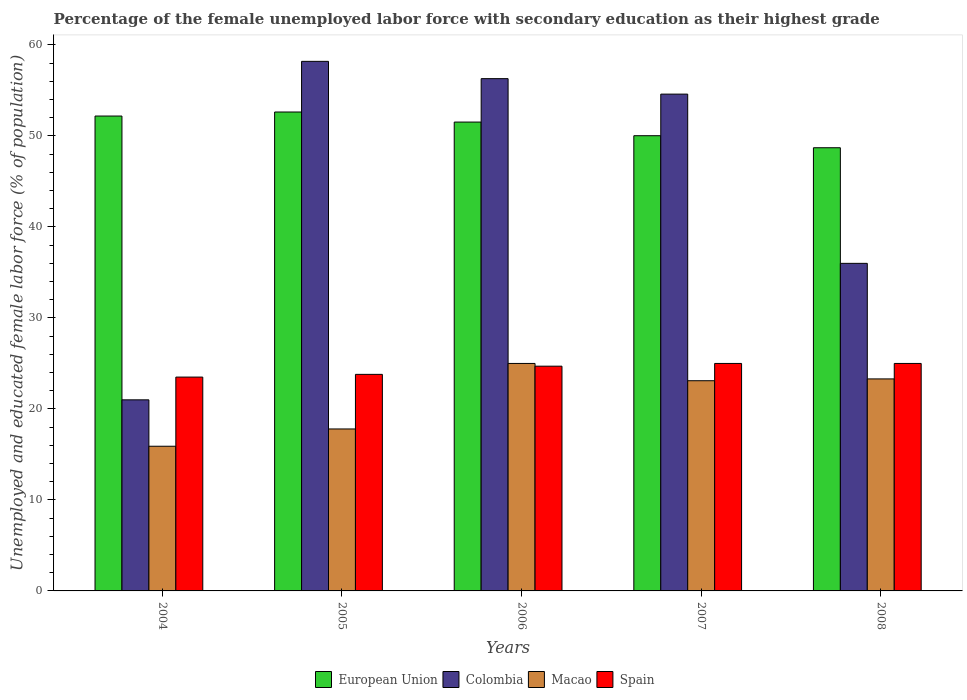Are the number of bars per tick equal to the number of legend labels?
Your answer should be compact. Yes. What is the label of the 1st group of bars from the left?
Your answer should be compact. 2004. What is the percentage of the unemployed female labor force with secondary education in Spain in 2007?
Offer a very short reply. 25. Across all years, what is the maximum percentage of the unemployed female labor force with secondary education in Macao?
Provide a succinct answer. 25. Across all years, what is the minimum percentage of the unemployed female labor force with secondary education in Macao?
Offer a terse response. 15.9. What is the total percentage of the unemployed female labor force with secondary education in European Union in the graph?
Your answer should be very brief. 255.08. What is the difference between the percentage of the unemployed female labor force with secondary education in Spain in 2005 and that in 2007?
Your response must be concise. -1.2. What is the difference between the percentage of the unemployed female labor force with secondary education in Spain in 2005 and the percentage of the unemployed female labor force with secondary education in Macao in 2004?
Your answer should be compact. 7.9. What is the average percentage of the unemployed female labor force with secondary education in Spain per year?
Offer a terse response. 24.4. In the year 2007, what is the difference between the percentage of the unemployed female labor force with secondary education in Spain and percentage of the unemployed female labor force with secondary education in Colombia?
Offer a very short reply. -29.6. In how many years, is the percentage of the unemployed female labor force with secondary education in European Union greater than 44 %?
Your response must be concise. 5. What is the ratio of the percentage of the unemployed female labor force with secondary education in Colombia in 2004 to that in 2005?
Make the answer very short. 0.36. Is the percentage of the unemployed female labor force with secondary education in Colombia in 2006 less than that in 2008?
Your response must be concise. No. Is the difference between the percentage of the unemployed female labor force with secondary education in Spain in 2006 and 2008 greater than the difference between the percentage of the unemployed female labor force with secondary education in Colombia in 2006 and 2008?
Give a very brief answer. No. What is the difference between the highest and the second highest percentage of the unemployed female labor force with secondary education in Spain?
Give a very brief answer. 0. What is the difference between the highest and the lowest percentage of the unemployed female labor force with secondary education in Macao?
Your answer should be compact. 9.1. In how many years, is the percentage of the unemployed female labor force with secondary education in Spain greater than the average percentage of the unemployed female labor force with secondary education in Spain taken over all years?
Offer a very short reply. 3. What does the 1st bar from the left in 2006 represents?
Your answer should be compact. European Union. What does the 1st bar from the right in 2006 represents?
Provide a succinct answer. Spain. How many bars are there?
Offer a terse response. 20. How many years are there in the graph?
Offer a terse response. 5. What is the difference between two consecutive major ticks on the Y-axis?
Offer a very short reply. 10. Does the graph contain grids?
Keep it short and to the point. No. What is the title of the graph?
Offer a very short reply. Percentage of the female unemployed labor force with secondary education as their highest grade. Does "United Kingdom" appear as one of the legend labels in the graph?
Offer a terse response. No. What is the label or title of the X-axis?
Your response must be concise. Years. What is the label or title of the Y-axis?
Give a very brief answer. Unemployed and educated female labor force (% of population). What is the Unemployed and educated female labor force (% of population) in European Union in 2004?
Keep it short and to the point. 52.19. What is the Unemployed and educated female labor force (% of population) of Macao in 2004?
Ensure brevity in your answer.  15.9. What is the Unemployed and educated female labor force (% of population) in Spain in 2004?
Ensure brevity in your answer.  23.5. What is the Unemployed and educated female labor force (% of population) in European Union in 2005?
Ensure brevity in your answer.  52.63. What is the Unemployed and educated female labor force (% of population) of Colombia in 2005?
Keep it short and to the point. 58.2. What is the Unemployed and educated female labor force (% of population) in Macao in 2005?
Your response must be concise. 17.8. What is the Unemployed and educated female labor force (% of population) in Spain in 2005?
Provide a succinct answer. 23.8. What is the Unemployed and educated female labor force (% of population) of European Union in 2006?
Provide a short and direct response. 51.53. What is the Unemployed and educated female labor force (% of population) in Colombia in 2006?
Provide a succinct answer. 56.3. What is the Unemployed and educated female labor force (% of population) of Macao in 2006?
Provide a succinct answer. 25. What is the Unemployed and educated female labor force (% of population) of Spain in 2006?
Your answer should be compact. 24.7. What is the Unemployed and educated female labor force (% of population) of European Union in 2007?
Your answer should be compact. 50.03. What is the Unemployed and educated female labor force (% of population) of Colombia in 2007?
Make the answer very short. 54.6. What is the Unemployed and educated female labor force (% of population) in Macao in 2007?
Provide a succinct answer. 23.1. What is the Unemployed and educated female labor force (% of population) in European Union in 2008?
Your answer should be compact. 48.71. What is the Unemployed and educated female labor force (% of population) in Macao in 2008?
Your response must be concise. 23.3. What is the Unemployed and educated female labor force (% of population) in Spain in 2008?
Give a very brief answer. 25. Across all years, what is the maximum Unemployed and educated female labor force (% of population) of European Union?
Give a very brief answer. 52.63. Across all years, what is the maximum Unemployed and educated female labor force (% of population) of Colombia?
Offer a terse response. 58.2. Across all years, what is the maximum Unemployed and educated female labor force (% of population) in Spain?
Your response must be concise. 25. Across all years, what is the minimum Unemployed and educated female labor force (% of population) of European Union?
Give a very brief answer. 48.71. Across all years, what is the minimum Unemployed and educated female labor force (% of population) of Colombia?
Give a very brief answer. 21. Across all years, what is the minimum Unemployed and educated female labor force (% of population) of Macao?
Your answer should be very brief. 15.9. What is the total Unemployed and educated female labor force (% of population) of European Union in the graph?
Offer a terse response. 255.08. What is the total Unemployed and educated female labor force (% of population) of Colombia in the graph?
Provide a short and direct response. 226.1. What is the total Unemployed and educated female labor force (% of population) in Macao in the graph?
Your answer should be compact. 105.1. What is the total Unemployed and educated female labor force (% of population) in Spain in the graph?
Your answer should be very brief. 122. What is the difference between the Unemployed and educated female labor force (% of population) of European Union in 2004 and that in 2005?
Ensure brevity in your answer.  -0.44. What is the difference between the Unemployed and educated female labor force (% of population) of Colombia in 2004 and that in 2005?
Provide a short and direct response. -37.2. What is the difference between the Unemployed and educated female labor force (% of population) in European Union in 2004 and that in 2006?
Offer a very short reply. 0.66. What is the difference between the Unemployed and educated female labor force (% of population) in Colombia in 2004 and that in 2006?
Provide a short and direct response. -35.3. What is the difference between the Unemployed and educated female labor force (% of population) in Spain in 2004 and that in 2006?
Ensure brevity in your answer.  -1.2. What is the difference between the Unemployed and educated female labor force (% of population) of European Union in 2004 and that in 2007?
Make the answer very short. 2.16. What is the difference between the Unemployed and educated female labor force (% of population) in Colombia in 2004 and that in 2007?
Provide a succinct answer. -33.6. What is the difference between the Unemployed and educated female labor force (% of population) of European Union in 2004 and that in 2008?
Your answer should be compact. 3.48. What is the difference between the Unemployed and educated female labor force (% of population) in European Union in 2005 and that in 2006?
Your response must be concise. 1.11. What is the difference between the Unemployed and educated female labor force (% of population) of Colombia in 2005 and that in 2006?
Offer a terse response. 1.9. What is the difference between the Unemployed and educated female labor force (% of population) of Spain in 2005 and that in 2006?
Ensure brevity in your answer.  -0.9. What is the difference between the Unemployed and educated female labor force (% of population) in European Union in 2005 and that in 2007?
Keep it short and to the point. 2.61. What is the difference between the Unemployed and educated female labor force (% of population) in Macao in 2005 and that in 2007?
Provide a succinct answer. -5.3. What is the difference between the Unemployed and educated female labor force (% of population) of European Union in 2005 and that in 2008?
Offer a terse response. 3.93. What is the difference between the Unemployed and educated female labor force (% of population) in Spain in 2005 and that in 2008?
Give a very brief answer. -1.2. What is the difference between the Unemployed and educated female labor force (% of population) of European Union in 2006 and that in 2008?
Provide a succinct answer. 2.82. What is the difference between the Unemployed and educated female labor force (% of population) of Colombia in 2006 and that in 2008?
Keep it short and to the point. 20.3. What is the difference between the Unemployed and educated female labor force (% of population) in European Union in 2007 and that in 2008?
Offer a very short reply. 1.32. What is the difference between the Unemployed and educated female labor force (% of population) in Colombia in 2007 and that in 2008?
Your response must be concise. 18.6. What is the difference between the Unemployed and educated female labor force (% of population) of Spain in 2007 and that in 2008?
Make the answer very short. 0. What is the difference between the Unemployed and educated female labor force (% of population) in European Union in 2004 and the Unemployed and educated female labor force (% of population) in Colombia in 2005?
Your answer should be compact. -6.01. What is the difference between the Unemployed and educated female labor force (% of population) of European Union in 2004 and the Unemployed and educated female labor force (% of population) of Macao in 2005?
Your answer should be compact. 34.39. What is the difference between the Unemployed and educated female labor force (% of population) in European Union in 2004 and the Unemployed and educated female labor force (% of population) in Spain in 2005?
Give a very brief answer. 28.39. What is the difference between the Unemployed and educated female labor force (% of population) in Macao in 2004 and the Unemployed and educated female labor force (% of population) in Spain in 2005?
Make the answer very short. -7.9. What is the difference between the Unemployed and educated female labor force (% of population) of European Union in 2004 and the Unemployed and educated female labor force (% of population) of Colombia in 2006?
Your answer should be very brief. -4.11. What is the difference between the Unemployed and educated female labor force (% of population) in European Union in 2004 and the Unemployed and educated female labor force (% of population) in Macao in 2006?
Your response must be concise. 27.19. What is the difference between the Unemployed and educated female labor force (% of population) of European Union in 2004 and the Unemployed and educated female labor force (% of population) of Spain in 2006?
Offer a terse response. 27.49. What is the difference between the Unemployed and educated female labor force (% of population) of Colombia in 2004 and the Unemployed and educated female labor force (% of population) of Spain in 2006?
Your answer should be very brief. -3.7. What is the difference between the Unemployed and educated female labor force (% of population) in European Union in 2004 and the Unemployed and educated female labor force (% of population) in Colombia in 2007?
Offer a terse response. -2.41. What is the difference between the Unemployed and educated female labor force (% of population) in European Union in 2004 and the Unemployed and educated female labor force (% of population) in Macao in 2007?
Keep it short and to the point. 29.09. What is the difference between the Unemployed and educated female labor force (% of population) in European Union in 2004 and the Unemployed and educated female labor force (% of population) in Spain in 2007?
Offer a very short reply. 27.19. What is the difference between the Unemployed and educated female labor force (% of population) of Colombia in 2004 and the Unemployed and educated female labor force (% of population) of Macao in 2007?
Your answer should be very brief. -2.1. What is the difference between the Unemployed and educated female labor force (% of population) of Colombia in 2004 and the Unemployed and educated female labor force (% of population) of Spain in 2007?
Provide a succinct answer. -4. What is the difference between the Unemployed and educated female labor force (% of population) in European Union in 2004 and the Unemployed and educated female labor force (% of population) in Colombia in 2008?
Keep it short and to the point. 16.19. What is the difference between the Unemployed and educated female labor force (% of population) in European Union in 2004 and the Unemployed and educated female labor force (% of population) in Macao in 2008?
Your answer should be very brief. 28.89. What is the difference between the Unemployed and educated female labor force (% of population) in European Union in 2004 and the Unemployed and educated female labor force (% of population) in Spain in 2008?
Provide a succinct answer. 27.19. What is the difference between the Unemployed and educated female labor force (% of population) in Colombia in 2004 and the Unemployed and educated female labor force (% of population) in Spain in 2008?
Provide a short and direct response. -4. What is the difference between the Unemployed and educated female labor force (% of population) in European Union in 2005 and the Unemployed and educated female labor force (% of population) in Colombia in 2006?
Make the answer very short. -3.67. What is the difference between the Unemployed and educated female labor force (% of population) in European Union in 2005 and the Unemployed and educated female labor force (% of population) in Macao in 2006?
Offer a terse response. 27.63. What is the difference between the Unemployed and educated female labor force (% of population) of European Union in 2005 and the Unemployed and educated female labor force (% of population) of Spain in 2006?
Your answer should be compact. 27.93. What is the difference between the Unemployed and educated female labor force (% of population) of Colombia in 2005 and the Unemployed and educated female labor force (% of population) of Macao in 2006?
Your answer should be very brief. 33.2. What is the difference between the Unemployed and educated female labor force (% of population) of Colombia in 2005 and the Unemployed and educated female labor force (% of population) of Spain in 2006?
Offer a very short reply. 33.5. What is the difference between the Unemployed and educated female labor force (% of population) in Macao in 2005 and the Unemployed and educated female labor force (% of population) in Spain in 2006?
Offer a very short reply. -6.9. What is the difference between the Unemployed and educated female labor force (% of population) of European Union in 2005 and the Unemployed and educated female labor force (% of population) of Colombia in 2007?
Give a very brief answer. -1.97. What is the difference between the Unemployed and educated female labor force (% of population) of European Union in 2005 and the Unemployed and educated female labor force (% of population) of Macao in 2007?
Your response must be concise. 29.53. What is the difference between the Unemployed and educated female labor force (% of population) in European Union in 2005 and the Unemployed and educated female labor force (% of population) in Spain in 2007?
Offer a terse response. 27.63. What is the difference between the Unemployed and educated female labor force (% of population) of Colombia in 2005 and the Unemployed and educated female labor force (% of population) of Macao in 2007?
Give a very brief answer. 35.1. What is the difference between the Unemployed and educated female labor force (% of population) in Colombia in 2005 and the Unemployed and educated female labor force (% of population) in Spain in 2007?
Your answer should be compact. 33.2. What is the difference between the Unemployed and educated female labor force (% of population) of European Union in 2005 and the Unemployed and educated female labor force (% of population) of Colombia in 2008?
Offer a terse response. 16.63. What is the difference between the Unemployed and educated female labor force (% of population) of European Union in 2005 and the Unemployed and educated female labor force (% of population) of Macao in 2008?
Offer a very short reply. 29.33. What is the difference between the Unemployed and educated female labor force (% of population) in European Union in 2005 and the Unemployed and educated female labor force (% of population) in Spain in 2008?
Your response must be concise. 27.63. What is the difference between the Unemployed and educated female labor force (% of population) in Colombia in 2005 and the Unemployed and educated female labor force (% of population) in Macao in 2008?
Provide a short and direct response. 34.9. What is the difference between the Unemployed and educated female labor force (% of population) of Colombia in 2005 and the Unemployed and educated female labor force (% of population) of Spain in 2008?
Keep it short and to the point. 33.2. What is the difference between the Unemployed and educated female labor force (% of population) in Macao in 2005 and the Unemployed and educated female labor force (% of population) in Spain in 2008?
Your response must be concise. -7.2. What is the difference between the Unemployed and educated female labor force (% of population) in European Union in 2006 and the Unemployed and educated female labor force (% of population) in Colombia in 2007?
Your answer should be compact. -3.07. What is the difference between the Unemployed and educated female labor force (% of population) in European Union in 2006 and the Unemployed and educated female labor force (% of population) in Macao in 2007?
Offer a terse response. 28.43. What is the difference between the Unemployed and educated female labor force (% of population) of European Union in 2006 and the Unemployed and educated female labor force (% of population) of Spain in 2007?
Offer a terse response. 26.53. What is the difference between the Unemployed and educated female labor force (% of population) of Colombia in 2006 and the Unemployed and educated female labor force (% of population) of Macao in 2007?
Offer a terse response. 33.2. What is the difference between the Unemployed and educated female labor force (% of population) of Colombia in 2006 and the Unemployed and educated female labor force (% of population) of Spain in 2007?
Your response must be concise. 31.3. What is the difference between the Unemployed and educated female labor force (% of population) in European Union in 2006 and the Unemployed and educated female labor force (% of population) in Colombia in 2008?
Provide a succinct answer. 15.53. What is the difference between the Unemployed and educated female labor force (% of population) in European Union in 2006 and the Unemployed and educated female labor force (% of population) in Macao in 2008?
Provide a short and direct response. 28.23. What is the difference between the Unemployed and educated female labor force (% of population) of European Union in 2006 and the Unemployed and educated female labor force (% of population) of Spain in 2008?
Offer a very short reply. 26.53. What is the difference between the Unemployed and educated female labor force (% of population) of Colombia in 2006 and the Unemployed and educated female labor force (% of population) of Macao in 2008?
Offer a very short reply. 33. What is the difference between the Unemployed and educated female labor force (% of population) in Colombia in 2006 and the Unemployed and educated female labor force (% of population) in Spain in 2008?
Your response must be concise. 31.3. What is the difference between the Unemployed and educated female labor force (% of population) in Macao in 2006 and the Unemployed and educated female labor force (% of population) in Spain in 2008?
Your response must be concise. 0. What is the difference between the Unemployed and educated female labor force (% of population) in European Union in 2007 and the Unemployed and educated female labor force (% of population) in Colombia in 2008?
Your response must be concise. 14.03. What is the difference between the Unemployed and educated female labor force (% of population) of European Union in 2007 and the Unemployed and educated female labor force (% of population) of Macao in 2008?
Provide a succinct answer. 26.73. What is the difference between the Unemployed and educated female labor force (% of population) in European Union in 2007 and the Unemployed and educated female labor force (% of population) in Spain in 2008?
Your response must be concise. 25.03. What is the difference between the Unemployed and educated female labor force (% of population) of Colombia in 2007 and the Unemployed and educated female labor force (% of population) of Macao in 2008?
Provide a succinct answer. 31.3. What is the difference between the Unemployed and educated female labor force (% of population) of Colombia in 2007 and the Unemployed and educated female labor force (% of population) of Spain in 2008?
Offer a terse response. 29.6. What is the average Unemployed and educated female labor force (% of population) of European Union per year?
Ensure brevity in your answer.  51.02. What is the average Unemployed and educated female labor force (% of population) of Colombia per year?
Provide a succinct answer. 45.22. What is the average Unemployed and educated female labor force (% of population) of Macao per year?
Provide a succinct answer. 21.02. What is the average Unemployed and educated female labor force (% of population) in Spain per year?
Provide a short and direct response. 24.4. In the year 2004, what is the difference between the Unemployed and educated female labor force (% of population) in European Union and Unemployed and educated female labor force (% of population) in Colombia?
Offer a very short reply. 31.19. In the year 2004, what is the difference between the Unemployed and educated female labor force (% of population) in European Union and Unemployed and educated female labor force (% of population) in Macao?
Your response must be concise. 36.29. In the year 2004, what is the difference between the Unemployed and educated female labor force (% of population) of European Union and Unemployed and educated female labor force (% of population) of Spain?
Keep it short and to the point. 28.69. In the year 2004, what is the difference between the Unemployed and educated female labor force (% of population) in Colombia and Unemployed and educated female labor force (% of population) in Macao?
Keep it short and to the point. 5.1. In the year 2004, what is the difference between the Unemployed and educated female labor force (% of population) of Colombia and Unemployed and educated female labor force (% of population) of Spain?
Your response must be concise. -2.5. In the year 2004, what is the difference between the Unemployed and educated female labor force (% of population) of Macao and Unemployed and educated female labor force (% of population) of Spain?
Your answer should be very brief. -7.6. In the year 2005, what is the difference between the Unemployed and educated female labor force (% of population) in European Union and Unemployed and educated female labor force (% of population) in Colombia?
Your answer should be very brief. -5.57. In the year 2005, what is the difference between the Unemployed and educated female labor force (% of population) of European Union and Unemployed and educated female labor force (% of population) of Macao?
Give a very brief answer. 34.83. In the year 2005, what is the difference between the Unemployed and educated female labor force (% of population) of European Union and Unemployed and educated female labor force (% of population) of Spain?
Make the answer very short. 28.83. In the year 2005, what is the difference between the Unemployed and educated female labor force (% of population) of Colombia and Unemployed and educated female labor force (% of population) of Macao?
Offer a terse response. 40.4. In the year 2005, what is the difference between the Unemployed and educated female labor force (% of population) of Colombia and Unemployed and educated female labor force (% of population) of Spain?
Make the answer very short. 34.4. In the year 2006, what is the difference between the Unemployed and educated female labor force (% of population) in European Union and Unemployed and educated female labor force (% of population) in Colombia?
Ensure brevity in your answer.  -4.77. In the year 2006, what is the difference between the Unemployed and educated female labor force (% of population) in European Union and Unemployed and educated female labor force (% of population) in Macao?
Offer a terse response. 26.53. In the year 2006, what is the difference between the Unemployed and educated female labor force (% of population) in European Union and Unemployed and educated female labor force (% of population) in Spain?
Keep it short and to the point. 26.83. In the year 2006, what is the difference between the Unemployed and educated female labor force (% of population) in Colombia and Unemployed and educated female labor force (% of population) in Macao?
Ensure brevity in your answer.  31.3. In the year 2006, what is the difference between the Unemployed and educated female labor force (% of population) in Colombia and Unemployed and educated female labor force (% of population) in Spain?
Offer a very short reply. 31.6. In the year 2006, what is the difference between the Unemployed and educated female labor force (% of population) of Macao and Unemployed and educated female labor force (% of population) of Spain?
Give a very brief answer. 0.3. In the year 2007, what is the difference between the Unemployed and educated female labor force (% of population) in European Union and Unemployed and educated female labor force (% of population) in Colombia?
Provide a succinct answer. -4.57. In the year 2007, what is the difference between the Unemployed and educated female labor force (% of population) of European Union and Unemployed and educated female labor force (% of population) of Macao?
Offer a terse response. 26.93. In the year 2007, what is the difference between the Unemployed and educated female labor force (% of population) in European Union and Unemployed and educated female labor force (% of population) in Spain?
Offer a very short reply. 25.03. In the year 2007, what is the difference between the Unemployed and educated female labor force (% of population) in Colombia and Unemployed and educated female labor force (% of population) in Macao?
Your answer should be compact. 31.5. In the year 2007, what is the difference between the Unemployed and educated female labor force (% of population) in Colombia and Unemployed and educated female labor force (% of population) in Spain?
Your answer should be compact. 29.6. In the year 2008, what is the difference between the Unemployed and educated female labor force (% of population) in European Union and Unemployed and educated female labor force (% of population) in Colombia?
Your answer should be very brief. 12.71. In the year 2008, what is the difference between the Unemployed and educated female labor force (% of population) in European Union and Unemployed and educated female labor force (% of population) in Macao?
Your answer should be compact. 25.41. In the year 2008, what is the difference between the Unemployed and educated female labor force (% of population) in European Union and Unemployed and educated female labor force (% of population) in Spain?
Your answer should be compact. 23.71. What is the ratio of the Unemployed and educated female labor force (% of population) in European Union in 2004 to that in 2005?
Provide a succinct answer. 0.99. What is the ratio of the Unemployed and educated female labor force (% of population) in Colombia in 2004 to that in 2005?
Give a very brief answer. 0.36. What is the ratio of the Unemployed and educated female labor force (% of population) in Macao in 2004 to that in 2005?
Your response must be concise. 0.89. What is the ratio of the Unemployed and educated female labor force (% of population) in Spain in 2004 to that in 2005?
Your answer should be compact. 0.99. What is the ratio of the Unemployed and educated female labor force (% of population) in European Union in 2004 to that in 2006?
Give a very brief answer. 1.01. What is the ratio of the Unemployed and educated female labor force (% of population) in Colombia in 2004 to that in 2006?
Ensure brevity in your answer.  0.37. What is the ratio of the Unemployed and educated female labor force (% of population) in Macao in 2004 to that in 2006?
Provide a succinct answer. 0.64. What is the ratio of the Unemployed and educated female labor force (% of population) of Spain in 2004 to that in 2006?
Your answer should be very brief. 0.95. What is the ratio of the Unemployed and educated female labor force (% of population) of European Union in 2004 to that in 2007?
Ensure brevity in your answer.  1.04. What is the ratio of the Unemployed and educated female labor force (% of population) of Colombia in 2004 to that in 2007?
Make the answer very short. 0.38. What is the ratio of the Unemployed and educated female labor force (% of population) in Macao in 2004 to that in 2007?
Your answer should be compact. 0.69. What is the ratio of the Unemployed and educated female labor force (% of population) in European Union in 2004 to that in 2008?
Your answer should be compact. 1.07. What is the ratio of the Unemployed and educated female labor force (% of population) in Colombia in 2004 to that in 2008?
Provide a succinct answer. 0.58. What is the ratio of the Unemployed and educated female labor force (% of population) in Macao in 2004 to that in 2008?
Your response must be concise. 0.68. What is the ratio of the Unemployed and educated female labor force (% of population) in European Union in 2005 to that in 2006?
Give a very brief answer. 1.02. What is the ratio of the Unemployed and educated female labor force (% of population) in Colombia in 2005 to that in 2006?
Keep it short and to the point. 1.03. What is the ratio of the Unemployed and educated female labor force (% of population) of Macao in 2005 to that in 2006?
Give a very brief answer. 0.71. What is the ratio of the Unemployed and educated female labor force (% of population) of Spain in 2005 to that in 2006?
Your response must be concise. 0.96. What is the ratio of the Unemployed and educated female labor force (% of population) in European Union in 2005 to that in 2007?
Provide a short and direct response. 1.05. What is the ratio of the Unemployed and educated female labor force (% of population) of Colombia in 2005 to that in 2007?
Ensure brevity in your answer.  1.07. What is the ratio of the Unemployed and educated female labor force (% of population) of Macao in 2005 to that in 2007?
Make the answer very short. 0.77. What is the ratio of the Unemployed and educated female labor force (% of population) of European Union in 2005 to that in 2008?
Offer a terse response. 1.08. What is the ratio of the Unemployed and educated female labor force (% of population) in Colombia in 2005 to that in 2008?
Give a very brief answer. 1.62. What is the ratio of the Unemployed and educated female labor force (% of population) of Macao in 2005 to that in 2008?
Offer a terse response. 0.76. What is the ratio of the Unemployed and educated female labor force (% of population) in Spain in 2005 to that in 2008?
Keep it short and to the point. 0.95. What is the ratio of the Unemployed and educated female labor force (% of population) in European Union in 2006 to that in 2007?
Keep it short and to the point. 1.03. What is the ratio of the Unemployed and educated female labor force (% of population) of Colombia in 2006 to that in 2007?
Provide a succinct answer. 1.03. What is the ratio of the Unemployed and educated female labor force (% of population) in Macao in 2006 to that in 2007?
Make the answer very short. 1.08. What is the ratio of the Unemployed and educated female labor force (% of population) of Spain in 2006 to that in 2007?
Offer a very short reply. 0.99. What is the ratio of the Unemployed and educated female labor force (% of population) of European Union in 2006 to that in 2008?
Ensure brevity in your answer.  1.06. What is the ratio of the Unemployed and educated female labor force (% of population) in Colombia in 2006 to that in 2008?
Provide a succinct answer. 1.56. What is the ratio of the Unemployed and educated female labor force (% of population) of Macao in 2006 to that in 2008?
Your answer should be very brief. 1.07. What is the ratio of the Unemployed and educated female labor force (% of population) of European Union in 2007 to that in 2008?
Ensure brevity in your answer.  1.03. What is the ratio of the Unemployed and educated female labor force (% of population) in Colombia in 2007 to that in 2008?
Your answer should be compact. 1.52. What is the ratio of the Unemployed and educated female labor force (% of population) in Macao in 2007 to that in 2008?
Your response must be concise. 0.99. What is the ratio of the Unemployed and educated female labor force (% of population) of Spain in 2007 to that in 2008?
Give a very brief answer. 1. What is the difference between the highest and the second highest Unemployed and educated female labor force (% of population) in European Union?
Offer a very short reply. 0.44. What is the difference between the highest and the second highest Unemployed and educated female labor force (% of population) of Colombia?
Provide a short and direct response. 1.9. What is the difference between the highest and the lowest Unemployed and educated female labor force (% of population) of European Union?
Provide a succinct answer. 3.93. What is the difference between the highest and the lowest Unemployed and educated female labor force (% of population) in Colombia?
Provide a short and direct response. 37.2. 